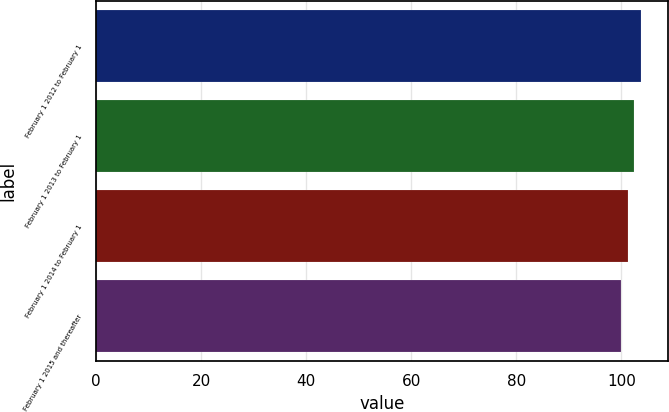<chart> <loc_0><loc_0><loc_500><loc_500><bar_chart><fcel>February 1 2012 to February 1<fcel>February 1 2013 to February 1<fcel>February 1 2014 to February 1<fcel>February 1 2015 and thereafter<nl><fcel>103.69<fcel>102.46<fcel>101.23<fcel>100<nl></chart> 